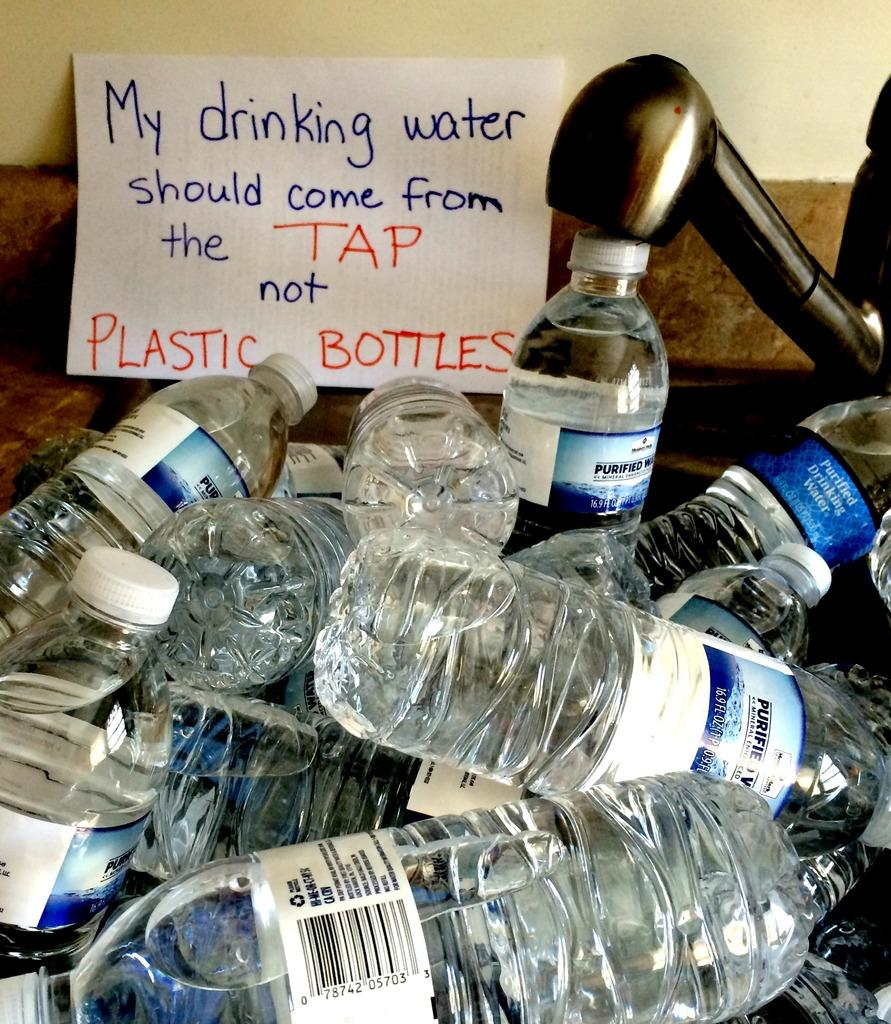What type of containers are visible in the image? There are water bottles in the image. What can be found on the water bottles? The water bottles have labels. Is there any additional item with writing in the image? Yes, there is a card with a note written on it in the image. What type of stick can be seen holding up the water bottles in the image? There is no stick holding up the water bottles in the image; they are likely standing on their own or placed on a surface. 